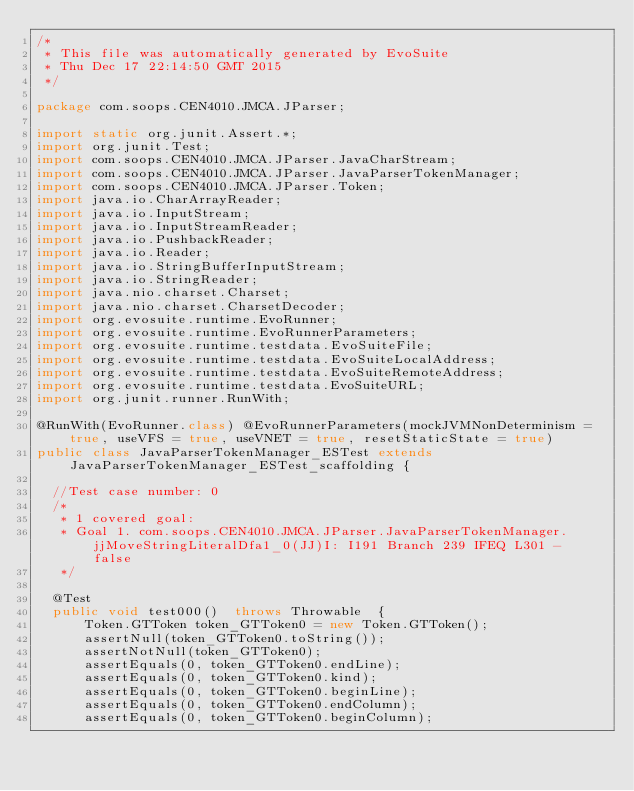<code> <loc_0><loc_0><loc_500><loc_500><_Java_>/*
 * This file was automatically generated by EvoSuite
 * Thu Dec 17 22:14:50 GMT 2015
 */

package com.soops.CEN4010.JMCA.JParser;

import static org.junit.Assert.*;
import org.junit.Test;
import com.soops.CEN4010.JMCA.JParser.JavaCharStream;
import com.soops.CEN4010.JMCA.JParser.JavaParserTokenManager;
import com.soops.CEN4010.JMCA.JParser.Token;
import java.io.CharArrayReader;
import java.io.InputStream;
import java.io.InputStreamReader;
import java.io.PushbackReader;
import java.io.Reader;
import java.io.StringBufferInputStream;
import java.io.StringReader;
import java.nio.charset.Charset;
import java.nio.charset.CharsetDecoder;
import org.evosuite.runtime.EvoRunner;
import org.evosuite.runtime.EvoRunnerParameters;
import org.evosuite.runtime.testdata.EvoSuiteFile;
import org.evosuite.runtime.testdata.EvoSuiteLocalAddress;
import org.evosuite.runtime.testdata.EvoSuiteRemoteAddress;
import org.evosuite.runtime.testdata.EvoSuiteURL;
import org.junit.runner.RunWith;

@RunWith(EvoRunner.class) @EvoRunnerParameters(mockJVMNonDeterminism = true, useVFS = true, useVNET = true, resetStaticState = true) 
public class JavaParserTokenManager_ESTest extends JavaParserTokenManager_ESTest_scaffolding {

  //Test case number: 0
  /*
   * 1 covered goal:
   * Goal 1. com.soops.CEN4010.JMCA.JParser.JavaParserTokenManager.jjMoveStringLiteralDfa1_0(JJ)I: I191 Branch 239 IFEQ L301 - false
   */

  @Test
  public void test000()  throws Throwable  {
      Token.GTToken token_GTToken0 = new Token.GTToken();
      assertNull(token_GTToken0.toString());
      assertNotNull(token_GTToken0);
      assertEquals(0, token_GTToken0.endLine);
      assertEquals(0, token_GTToken0.kind);
      assertEquals(0, token_GTToken0.beginLine);
      assertEquals(0, token_GTToken0.endColumn);
      assertEquals(0, token_GTToken0.beginColumn);
      </code> 